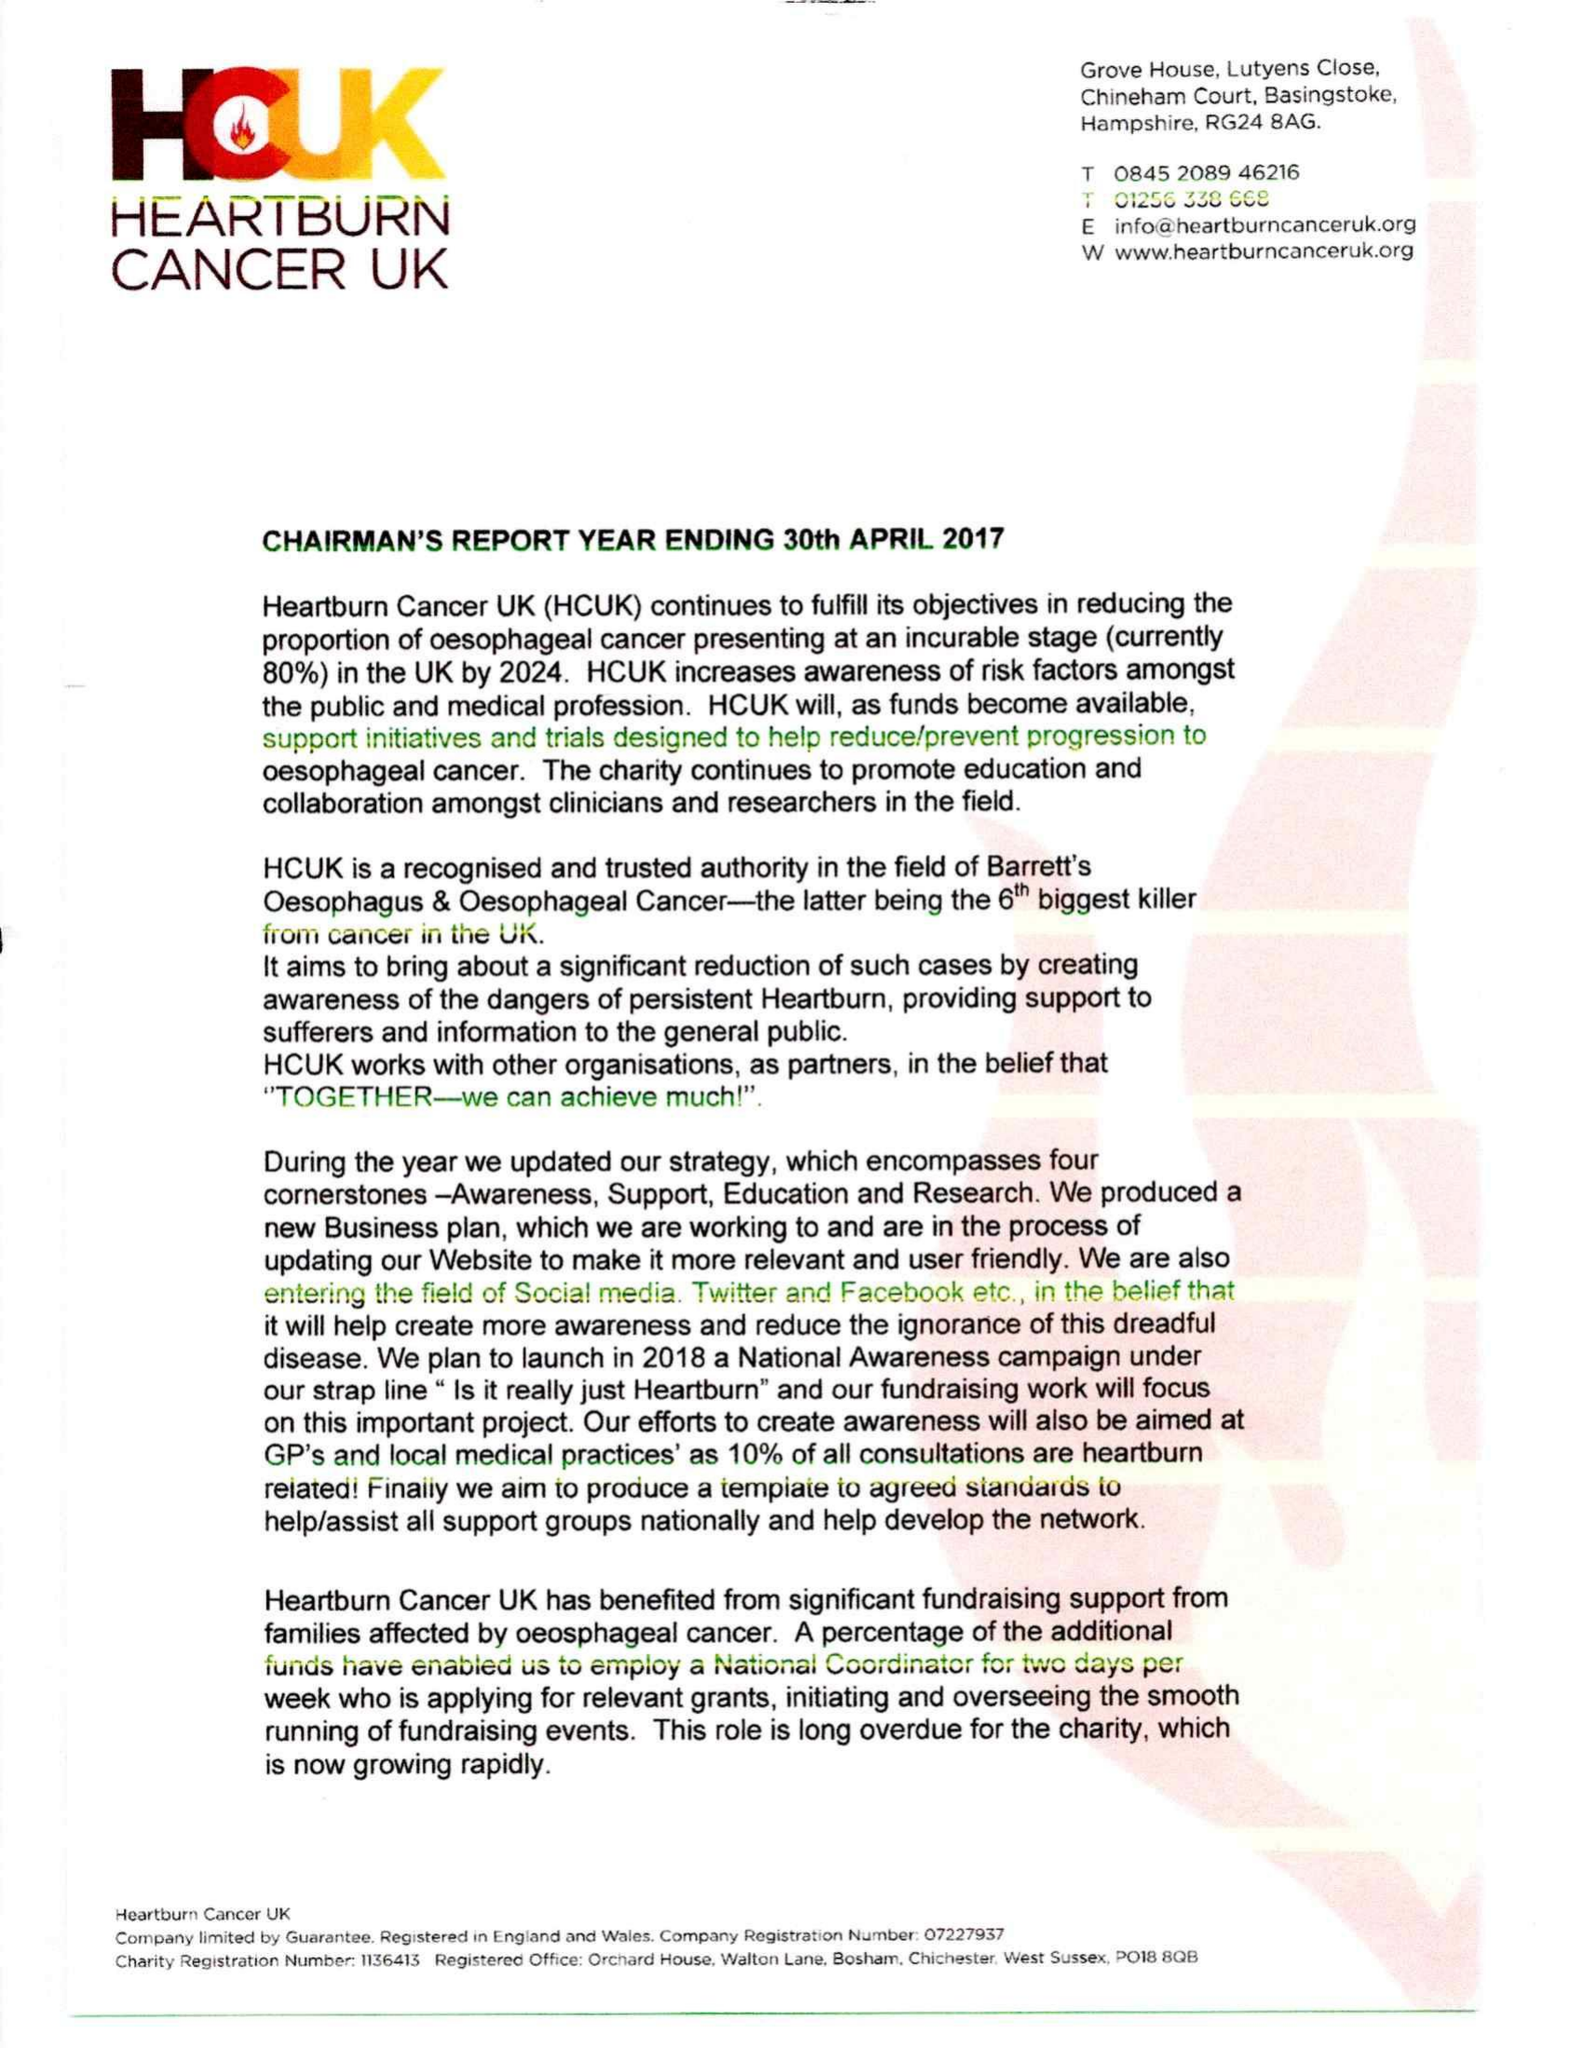What is the value for the address__post_town?
Answer the question using a single word or phrase. CHICHESTER 